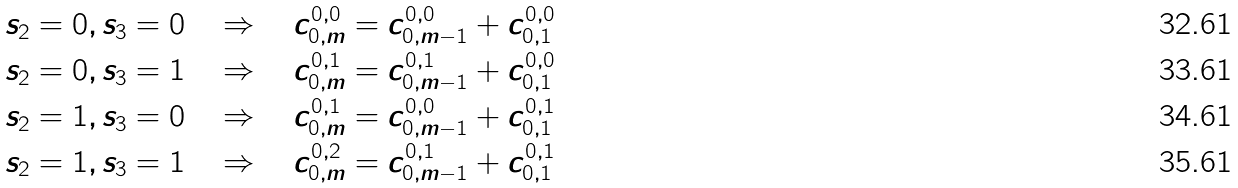<formula> <loc_0><loc_0><loc_500><loc_500>s _ { 2 } = 0 , s _ { 3 } = 0 \quad \Rightarrow \quad c _ { 0 , m } ^ { 0 , 0 } & = c _ { 0 , m - 1 } ^ { 0 , 0 } + c _ { 0 , 1 } ^ { 0 , 0 } \\ s _ { 2 } = 0 , s _ { 3 } = 1 \quad \Rightarrow \quad c _ { 0 , m } ^ { 0 , 1 } & = c _ { 0 , m - 1 } ^ { 0 , 1 } + c _ { 0 , 1 } ^ { 0 , 0 } \\ s _ { 2 } = 1 , s _ { 3 } = 0 \quad \Rightarrow \quad c _ { 0 , m } ^ { 0 , 1 } & = c _ { 0 , m - 1 } ^ { 0 , 0 } + c _ { 0 , 1 } ^ { 0 , 1 } \\ s _ { 2 } = 1 , s _ { 3 } = 1 \quad \Rightarrow \quad c _ { 0 , m } ^ { 0 , 2 } & = c _ { 0 , m - 1 } ^ { 0 , 1 } + c _ { 0 , 1 } ^ { 0 , 1 }</formula> 